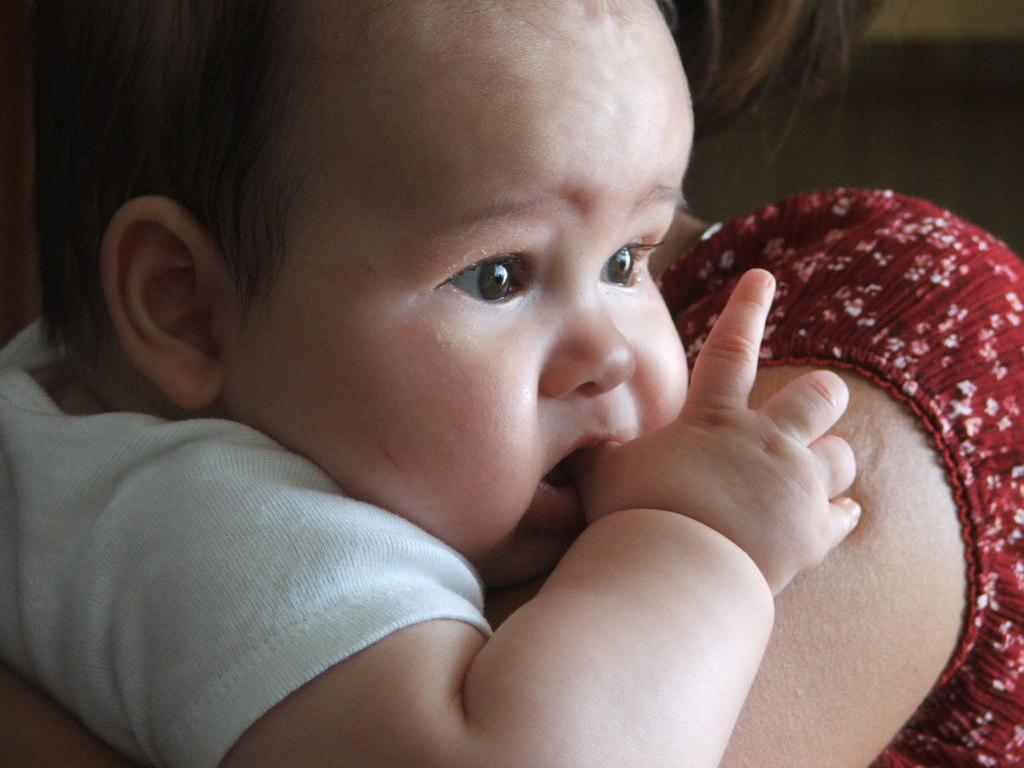What is the main subject of the image? The main subject of the image is a woman. What is the woman doing in the image? The woman is holding a baby. What type of card can be seen on the table in the garden? There is no card or table present in the image, and the image does not depict a garden. 